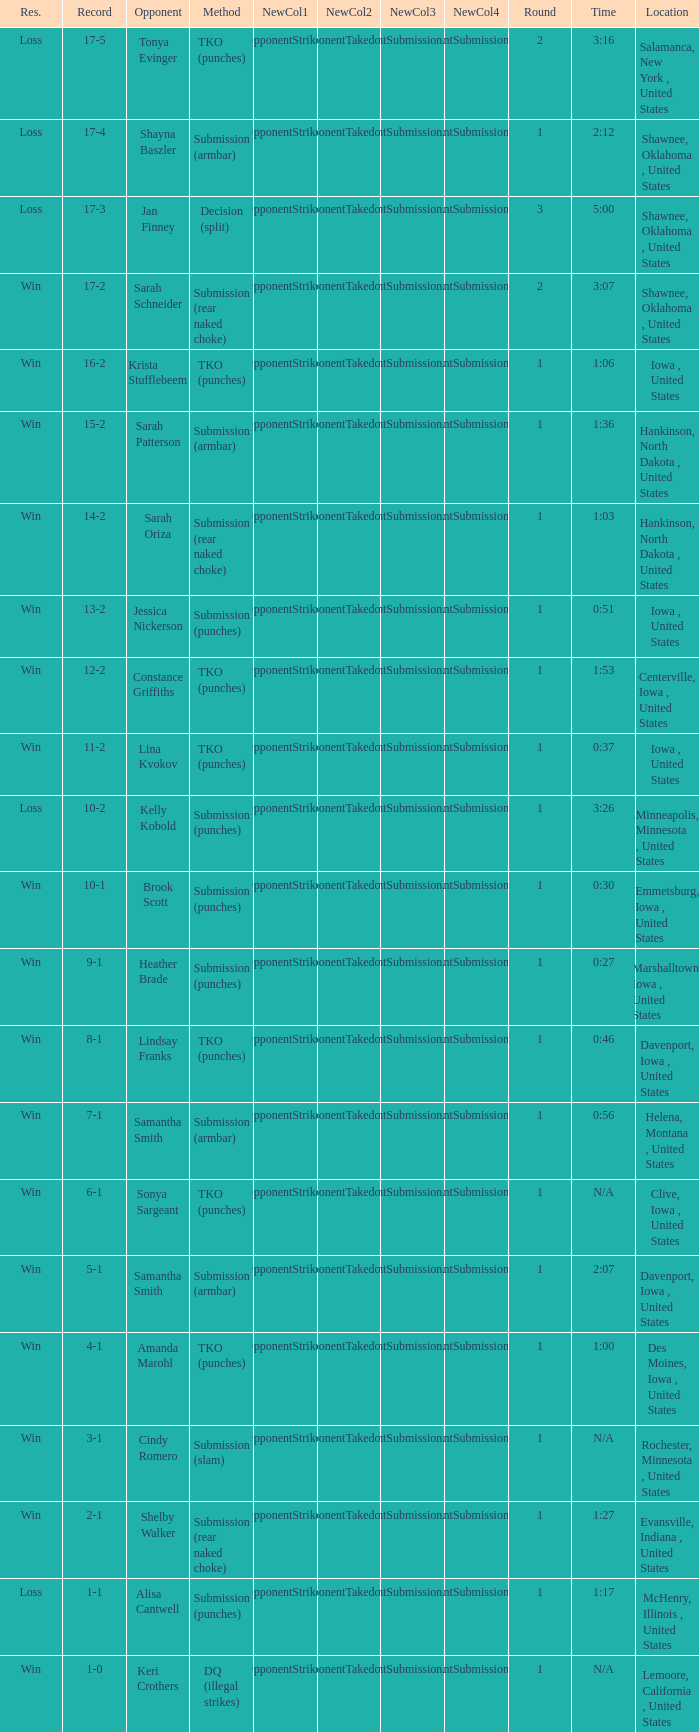What is the highest number of rounds for a 3:16 fight? 2.0. 